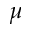<formula> <loc_0><loc_0><loc_500><loc_500>\mu</formula> 